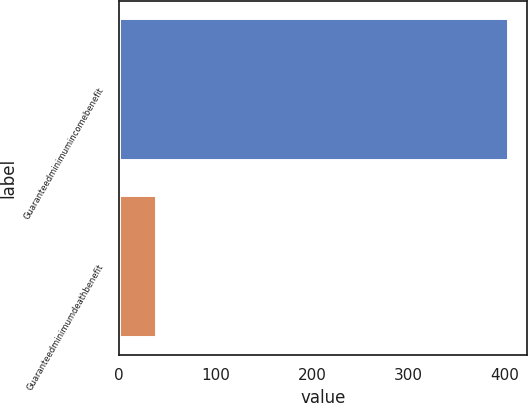<chart> <loc_0><loc_0><loc_500><loc_500><bar_chart><fcel>Guaranteedminimumincomebenefit<fcel>Guaranteedminimumdeathbenefit<nl><fcel>403<fcel>39<nl></chart> 